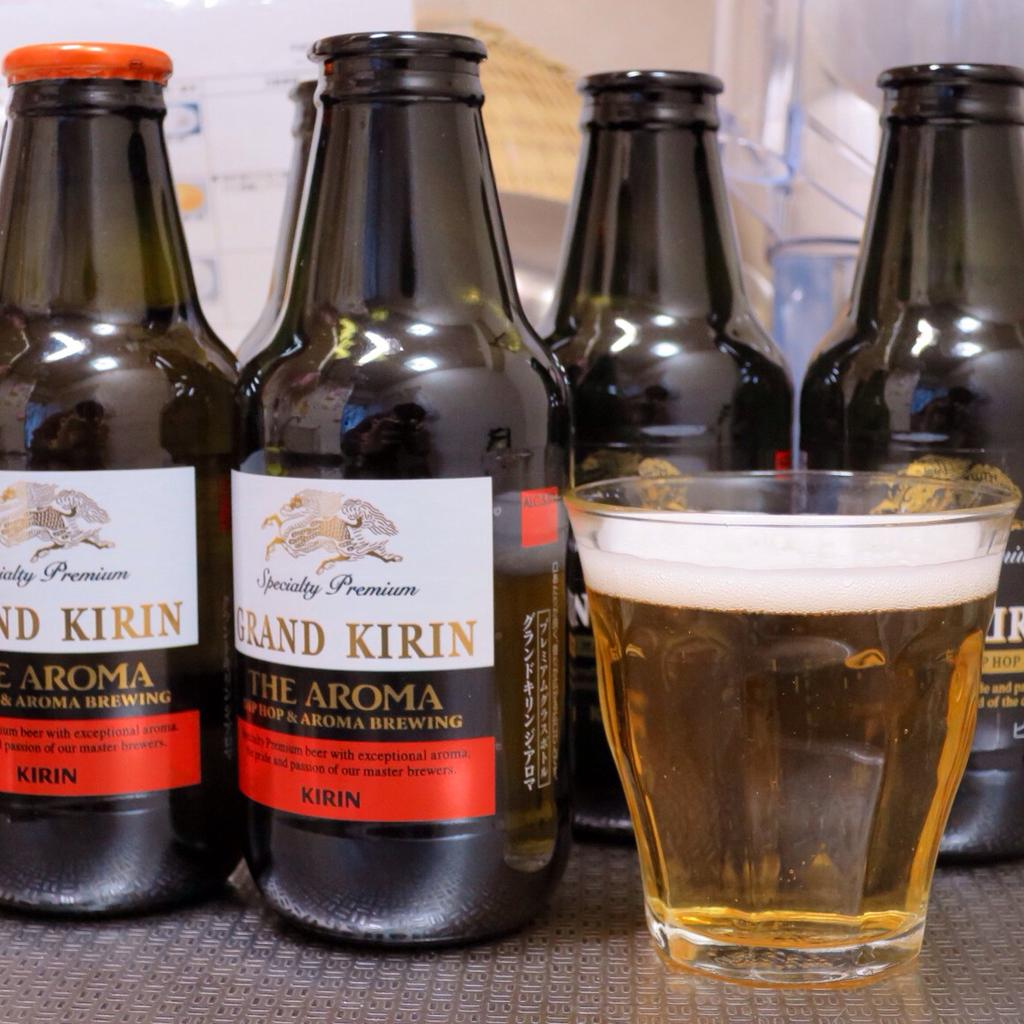Provide a one-sentence caption for the provided image. small beer bottles that say grand kirin the aroma on them. 